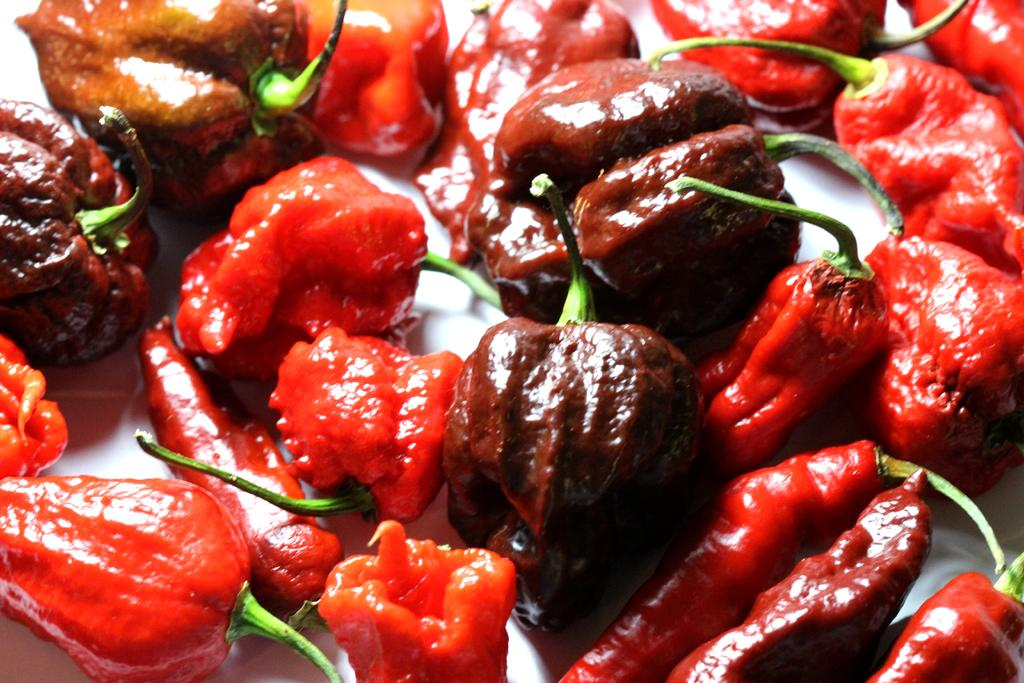What type of food item is visible in the image? There are pimentos present in the image. Where are the pimentos located in the image? The pimentos are over a place or surface. Who is the creator of the stove in the image? There is no stove present in the image, so it is not possible to determine the creator of a stove. 